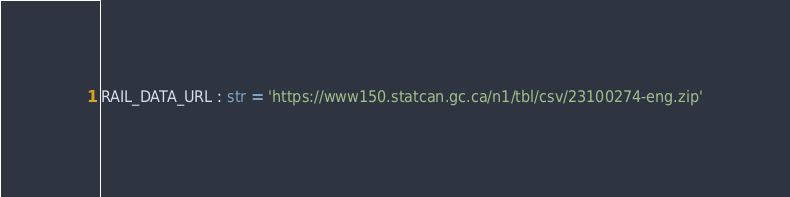<code> <loc_0><loc_0><loc_500><loc_500><_Python_>

RAIL_DATA_URL : str = 'https://www150.statcan.gc.ca/n1/tbl/csv/23100274-eng.zip'</code> 